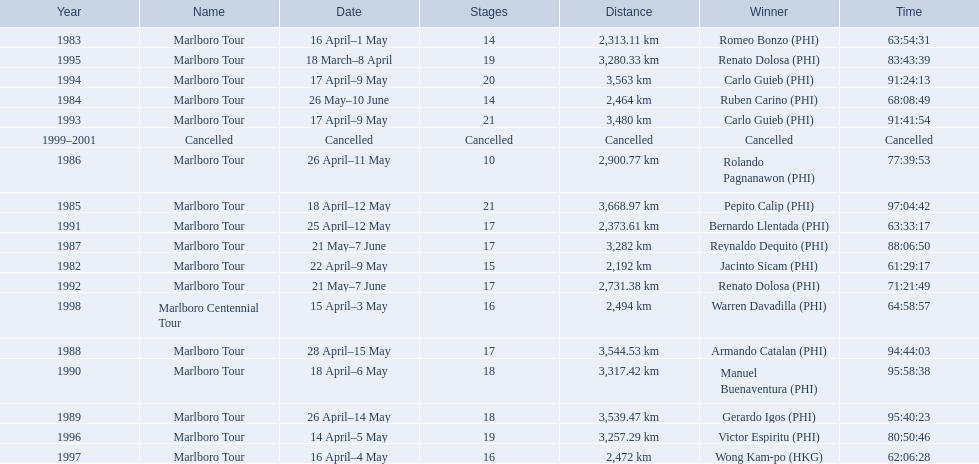What are the distances travelled on the tour? 2,192 km, 2,313.11 km, 2,464 km, 3,668.97 km, 2,900.77 km, 3,282 km, 3,544.53 km, 3,539.47 km, 3,317.42 km, 2,373.61 km, 2,731.38 km, 3,480 km, 3,563 km, 3,280.33 km, 3,257.29 km, 2,472 km, 2,494 km. Which of these are the largest? 3,668.97 km. 